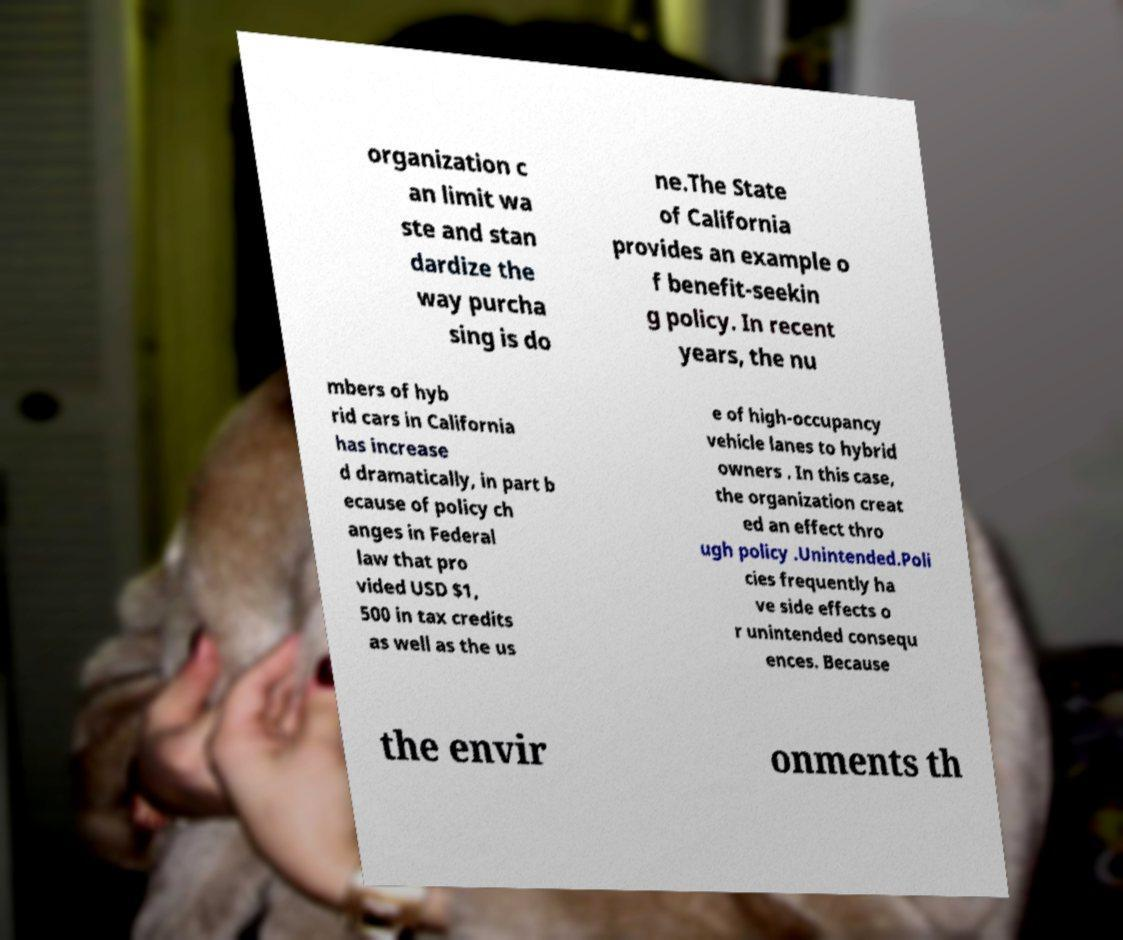What messages or text are displayed in this image? I need them in a readable, typed format. organization c an limit wa ste and stan dardize the way purcha sing is do ne.The State of California provides an example o f benefit-seekin g policy. In recent years, the nu mbers of hyb rid cars in California has increase d dramatically, in part b ecause of policy ch anges in Federal law that pro vided USD $1, 500 in tax credits as well as the us e of high-occupancy vehicle lanes to hybrid owners . In this case, the organization creat ed an effect thro ugh policy .Unintended.Poli cies frequently ha ve side effects o r unintended consequ ences. Because the envir onments th 